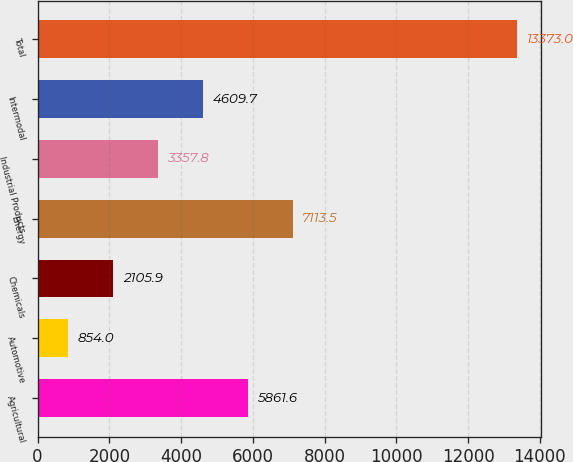Convert chart. <chart><loc_0><loc_0><loc_500><loc_500><bar_chart><fcel>Agricultural<fcel>Automotive<fcel>Chemicals<fcel>Energy<fcel>Industrial Products<fcel>Intermodal<fcel>Total<nl><fcel>5861.6<fcel>854<fcel>2105.9<fcel>7113.5<fcel>3357.8<fcel>4609.7<fcel>13373<nl></chart> 